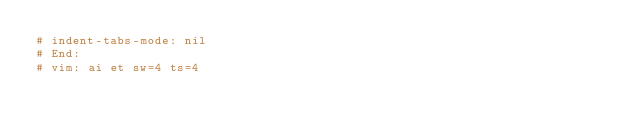<code> <loc_0><loc_0><loc_500><loc_500><_Bash_># indent-tabs-mode: nil
# End:
# vim: ai et sw=4 ts=4
</code> 